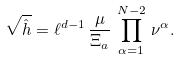<formula> <loc_0><loc_0><loc_500><loc_500>\sqrt { \hat { h } } = \ell ^ { d - 1 } \, \frac { \mu } { \Xi _ { a } } \, \prod _ { \alpha = 1 } ^ { N - 2 } \, \nu ^ { \alpha } .</formula> 